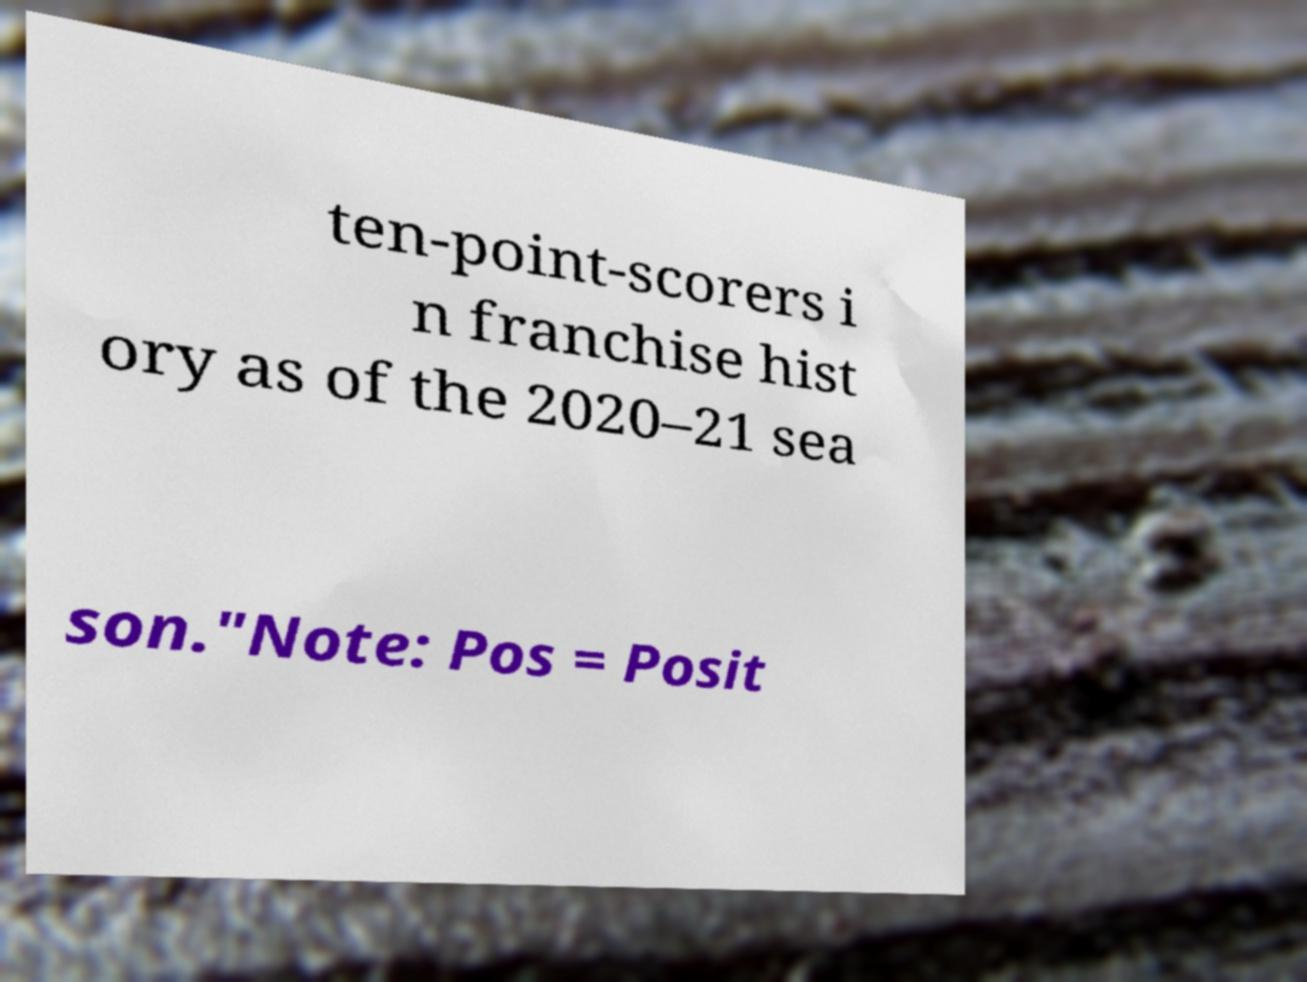Please identify and transcribe the text found in this image. ten-point-scorers i n franchise hist ory as of the 2020–21 sea son."Note: Pos = Posit 